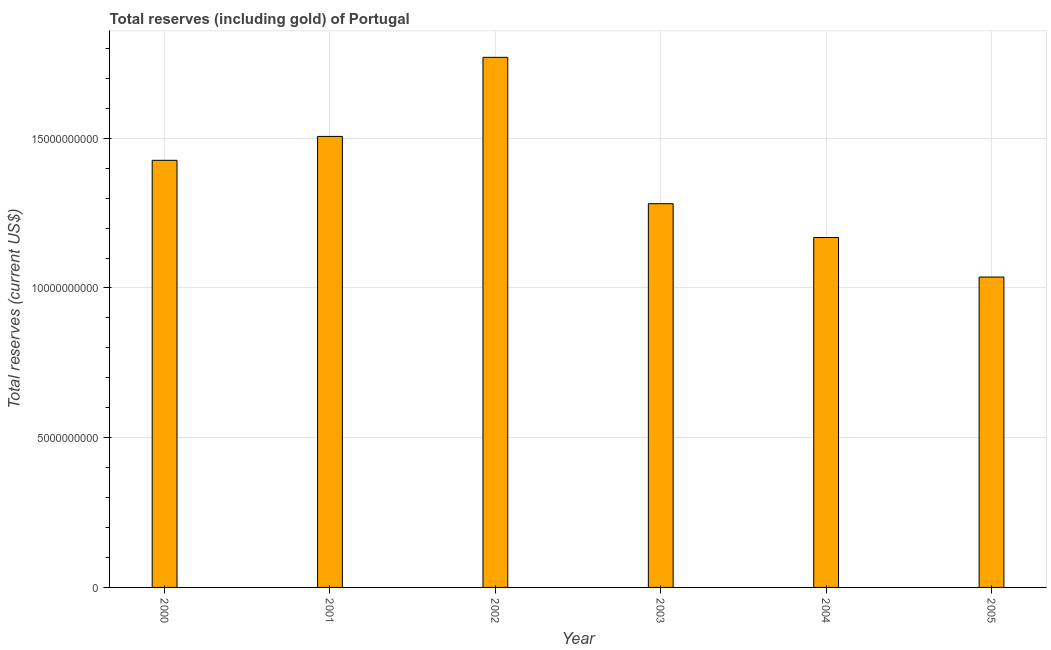Does the graph contain any zero values?
Provide a succinct answer. No. What is the title of the graph?
Give a very brief answer. Total reserves (including gold) of Portugal. What is the label or title of the X-axis?
Your answer should be very brief. Year. What is the label or title of the Y-axis?
Your answer should be very brief. Total reserves (current US$). What is the total reserves (including gold) in 2001?
Provide a short and direct response. 1.51e+1. Across all years, what is the maximum total reserves (including gold)?
Make the answer very short. 1.77e+1. Across all years, what is the minimum total reserves (including gold)?
Make the answer very short. 1.04e+1. In which year was the total reserves (including gold) minimum?
Offer a terse response. 2005. What is the sum of the total reserves (including gold)?
Offer a very short reply. 8.19e+1. What is the difference between the total reserves (including gold) in 2003 and 2004?
Your answer should be very brief. 1.13e+09. What is the average total reserves (including gold) per year?
Make the answer very short. 1.36e+1. What is the median total reserves (including gold)?
Keep it short and to the point. 1.35e+1. In how many years, is the total reserves (including gold) greater than 11000000000 US$?
Your answer should be very brief. 5. What is the ratio of the total reserves (including gold) in 2001 to that in 2004?
Ensure brevity in your answer.  1.29. What is the difference between the highest and the second highest total reserves (including gold)?
Provide a short and direct response. 2.64e+09. What is the difference between the highest and the lowest total reserves (including gold)?
Offer a very short reply. 7.34e+09. What is the Total reserves (current US$) of 2000?
Make the answer very short. 1.43e+1. What is the Total reserves (current US$) of 2001?
Provide a short and direct response. 1.51e+1. What is the Total reserves (current US$) in 2002?
Ensure brevity in your answer.  1.77e+1. What is the Total reserves (current US$) of 2003?
Keep it short and to the point. 1.28e+1. What is the Total reserves (current US$) in 2004?
Offer a very short reply. 1.17e+1. What is the Total reserves (current US$) of 2005?
Your answer should be very brief. 1.04e+1. What is the difference between the Total reserves (current US$) in 2000 and 2001?
Make the answer very short. -7.98e+08. What is the difference between the Total reserves (current US$) in 2000 and 2002?
Offer a very short reply. -3.44e+09. What is the difference between the Total reserves (current US$) in 2000 and 2003?
Make the answer very short. 1.45e+09. What is the difference between the Total reserves (current US$) in 2000 and 2004?
Offer a very short reply. 2.58e+09. What is the difference between the Total reserves (current US$) in 2000 and 2005?
Your answer should be very brief. 3.90e+09. What is the difference between the Total reserves (current US$) in 2001 and 2002?
Offer a terse response. -2.64e+09. What is the difference between the Total reserves (current US$) in 2001 and 2003?
Your response must be concise. 2.25e+09. What is the difference between the Total reserves (current US$) in 2001 and 2004?
Offer a terse response. 3.38e+09. What is the difference between the Total reserves (current US$) in 2001 and 2005?
Your answer should be very brief. 4.70e+09. What is the difference between the Total reserves (current US$) in 2002 and 2003?
Offer a very short reply. 4.89e+09. What is the difference between the Total reserves (current US$) in 2002 and 2004?
Offer a very short reply. 6.02e+09. What is the difference between the Total reserves (current US$) in 2002 and 2005?
Provide a short and direct response. 7.34e+09. What is the difference between the Total reserves (current US$) in 2003 and 2004?
Keep it short and to the point. 1.13e+09. What is the difference between the Total reserves (current US$) in 2003 and 2005?
Make the answer very short. 2.45e+09. What is the difference between the Total reserves (current US$) in 2004 and 2005?
Make the answer very short. 1.32e+09. What is the ratio of the Total reserves (current US$) in 2000 to that in 2001?
Keep it short and to the point. 0.95. What is the ratio of the Total reserves (current US$) in 2000 to that in 2002?
Offer a very short reply. 0.81. What is the ratio of the Total reserves (current US$) in 2000 to that in 2003?
Ensure brevity in your answer.  1.11. What is the ratio of the Total reserves (current US$) in 2000 to that in 2004?
Ensure brevity in your answer.  1.22. What is the ratio of the Total reserves (current US$) in 2000 to that in 2005?
Offer a very short reply. 1.38. What is the ratio of the Total reserves (current US$) in 2001 to that in 2002?
Make the answer very short. 0.85. What is the ratio of the Total reserves (current US$) in 2001 to that in 2003?
Provide a succinct answer. 1.18. What is the ratio of the Total reserves (current US$) in 2001 to that in 2004?
Your answer should be compact. 1.29. What is the ratio of the Total reserves (current US$) in 2001 to that in 2005?
Provide a short and direct response. 1.45. What is the ratio of the Total reserves (current US$) in 2002 to that in 2003?
Offer a terse response. 1.38. What is the ratio of the Total reserves (current US$) in 2002 to that in 2004?
Make the answer very short. 1.51. What is the ratio of the Total reserves (current US$) in 2002 to that in 2005?
Your answer should be compact. 1.71. What is the ratio of the Total reserves (current US$) in 2003 to that in 2004?
Offer a very short reply. 1.1. What is the ratio of the Total reserves (current US$) in 2003 to that in 2005?
Offer a very short reply. 1.24. What is the ratio of the Total reserves (current US$) in 2004 to that in 2005?
Provide a short and direct response. 1.13. 